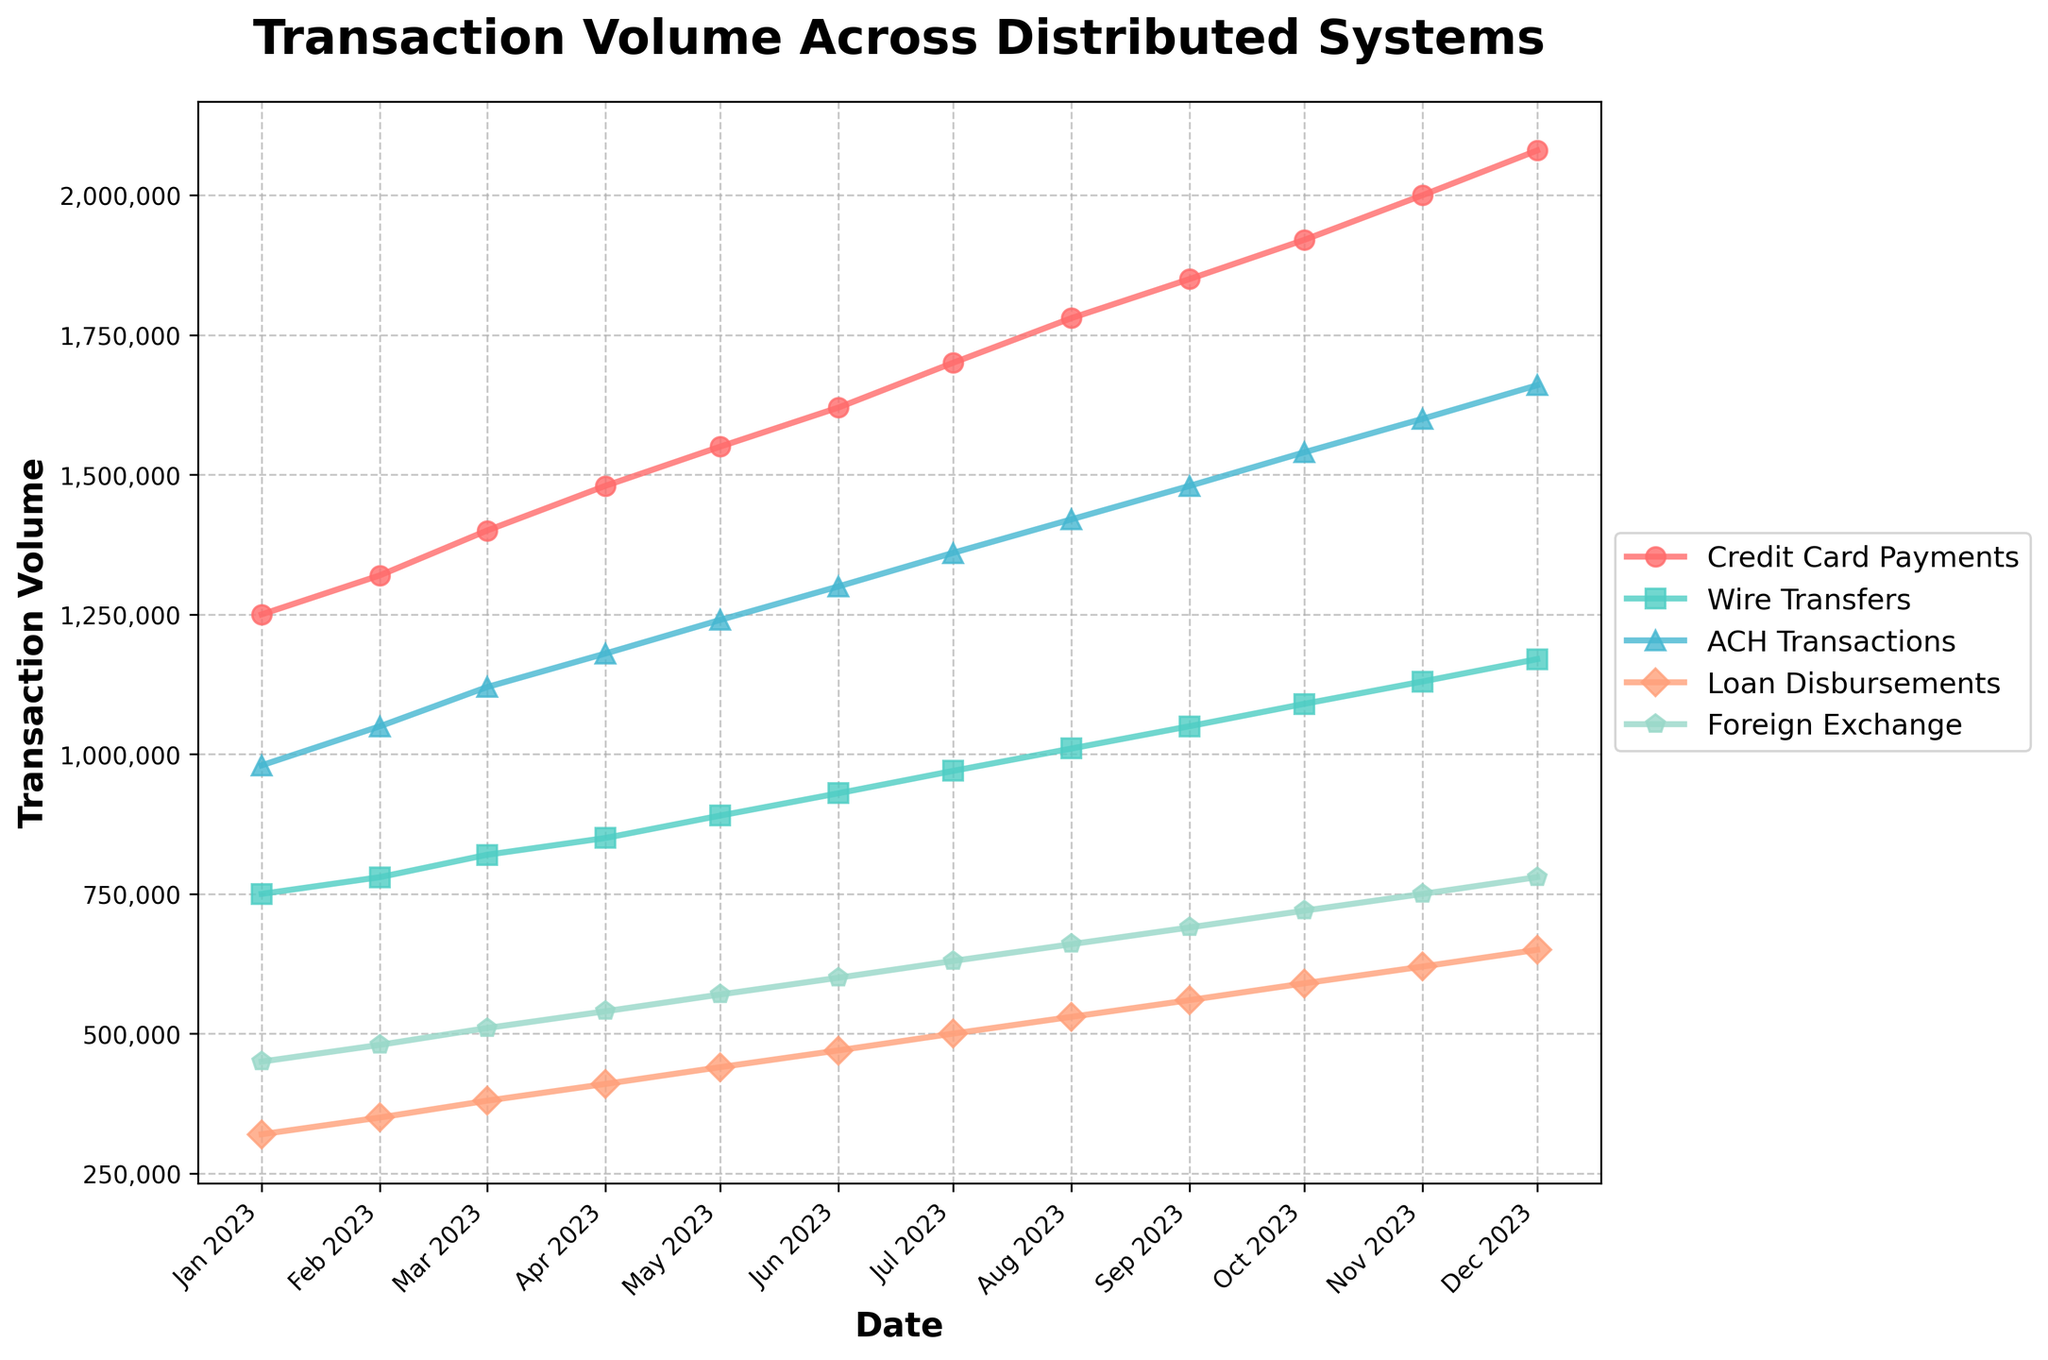What is the trend of Credit Card Payments over time? When looking at the line representing Credit Card Payments (the red line), the volume increases steadily each month from January 2023 to December 2023.
Answer: Steadily increasing Which transaction type has the highest volume in December 2023? From the plot, in December 2023, the line representing Credit Card Payments is the highest among all transaction types.
Answer: Credit Card Payments Compare the transaction volumes of Wire Transfers and ACH Transactions in July 2023. Which is higher and by how much? In July 2023, the volume of Wire Transfers is 970,000, and the volume of ACH Transactions is 1,360,000. To find the difference, you subtract 970,000 from 1,360,000.
Answer: ACH Transactions by 390,000 What is the average transaction volume of Loan Disbursements from January 2023 to December 2023? Sum the values of Loan Disbursements from January (320,000) to December (650,000), then divide by 12 (the number of months). The sum is 4,920,000, so 4,920,000 / 12 = 410,000.
Answer: 410,000 Between which two consecutive months is the largest increase in Foreign Exchange transactions observed? Observing the line representing Foreign Exchange transactions, the largest increase can be seen between November (750,000) and December (780,000), where the volume increases by 30,000.
Answer: November to December Does any transaction type show a decline in volume over the time period? By visually inspecting the lines for all transaction types, none of them show any decline from January to December; all show an increasing trend.
Answer: No In February 2023, how much more were Credit Card Payments compared to Foreign Exchange transactions? The volume of Credit Card Payments in February is 1,320,000, and Foreign Exchange transactions are 480,000. The difference is 1,320,000 - 480,000.
Answer: 840,000 How many times did the transaction volume of Wire Transfers exceed 1,000,000? From the chart, Wire Transfers only exceed 1,000,000 in September, October, November, and December, a total of 4 times.
Answer: 4 times What was the combined volume of Credit Card Payments and ACH Transactions in April 2023? To get the combined volume, sum the volumes of Credit Card Payments (1,480,000) and ACH Transactions (1,180,000) in April. The combined volume is 1,480,000 + 1,180,000.
Answer: 2,660,000 Which transaction type had the smallest volume in January 2023? From the chart, Loan Disbursements had the smallest volume in January 2023, represented by the orange line.
Answer: Loan Disbursements 